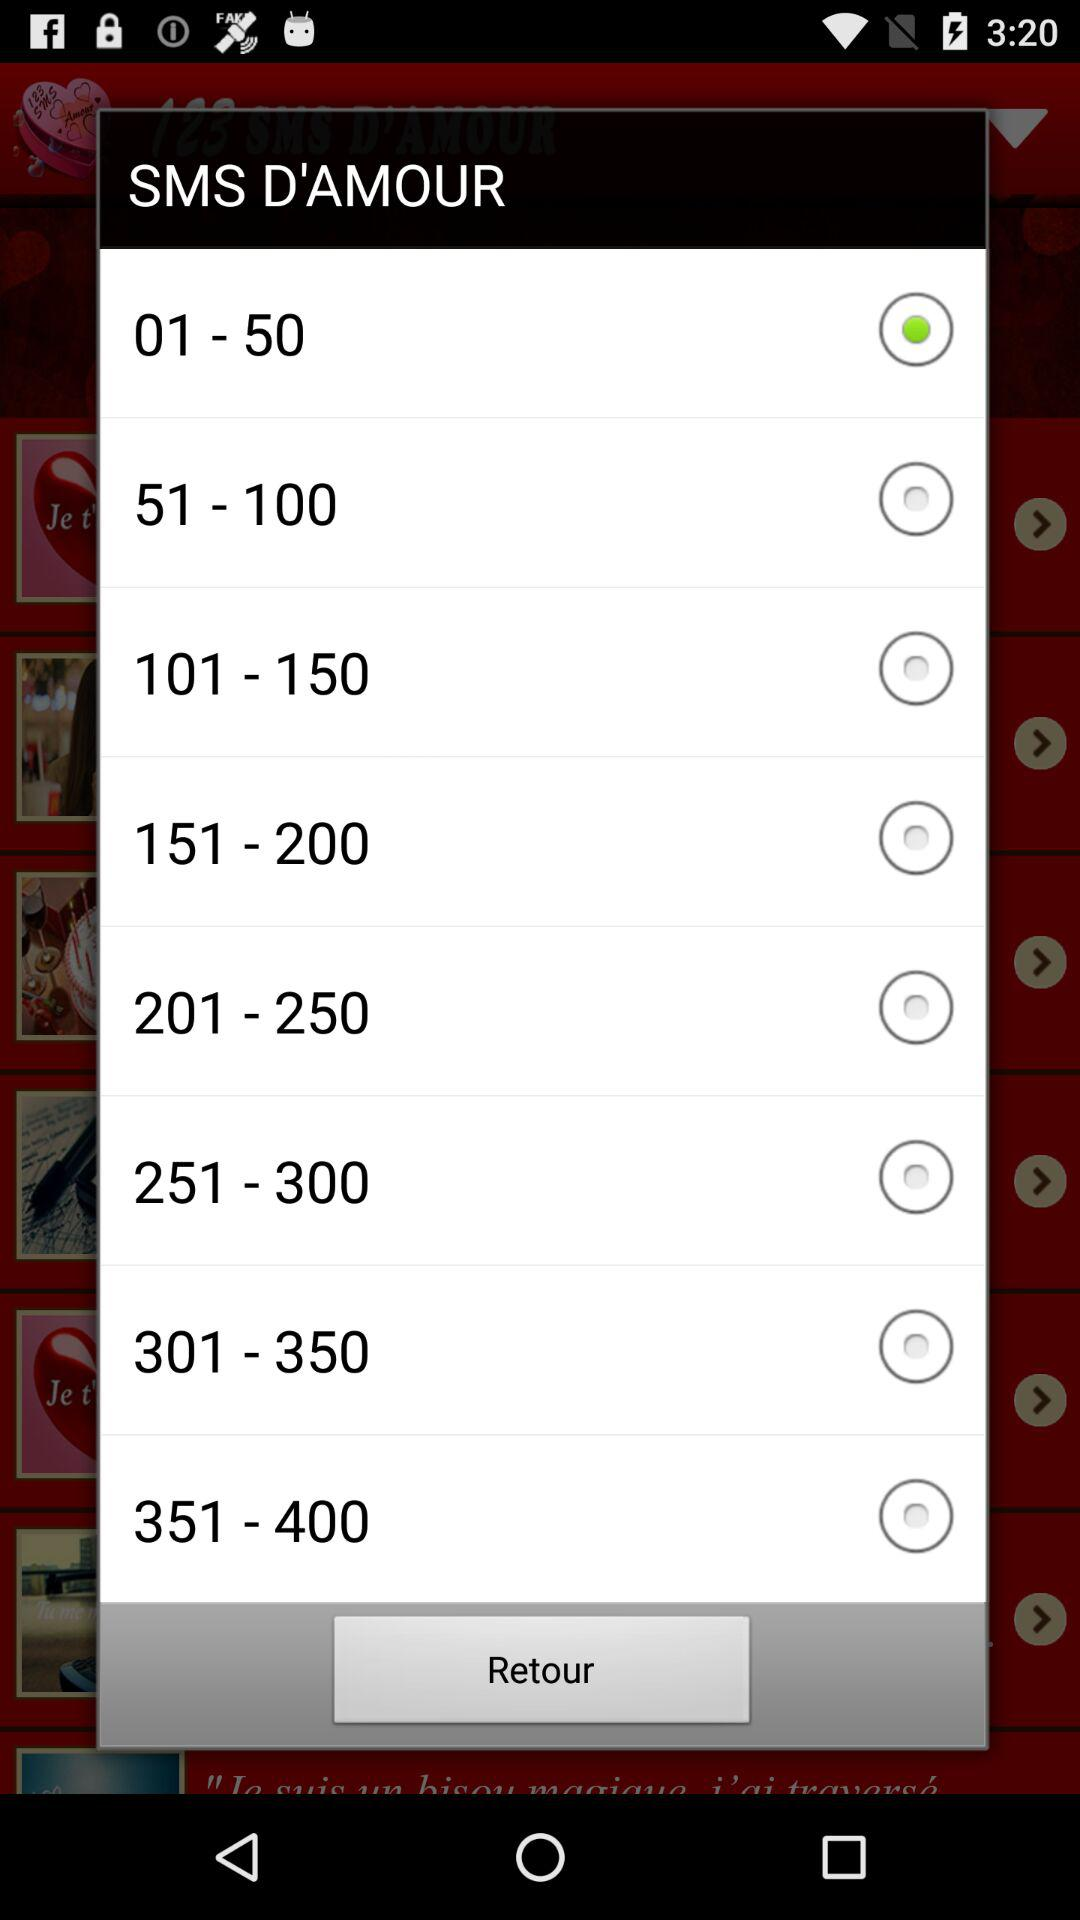Which range has been selected? The selected range is "01-50". 